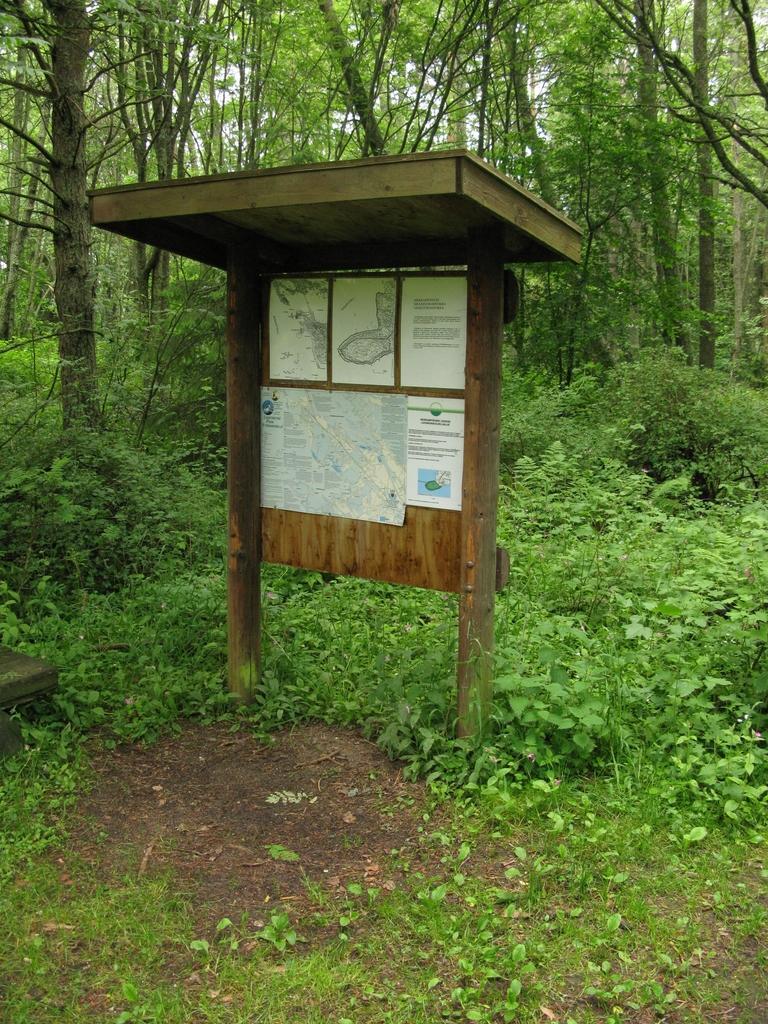Describe this image in one or two sentences. In this picture I can see plants, grass and trees. Here I can see a wooden object and a board which has some papers attached to it. 